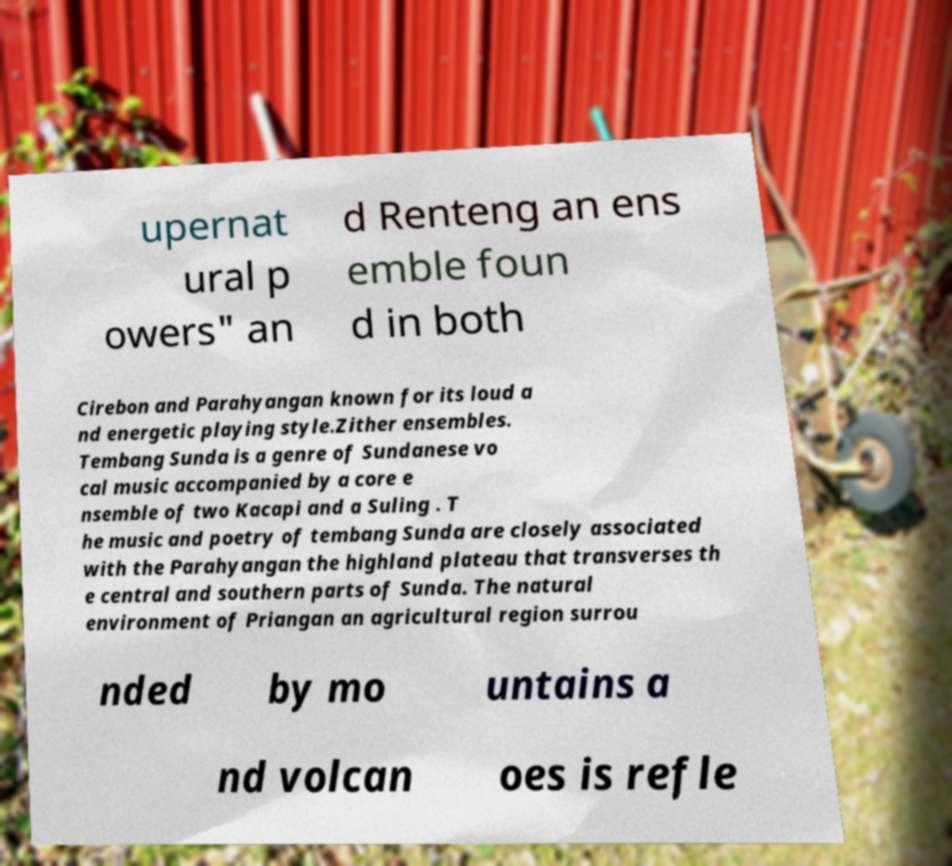I need the written content from this picture converted into text. Can you do that? upernat ural p owers" an d Renteng an ens emble foun d in both Cirebon and Parahyangan known for its loud a nd energetic playing style.Zither ensembles. Tembang Sunda is a genre of Sundanese vo cal music accompanied by a core e nsemble of two Kacapi and a Suling . T he music and poetry of tembang Sunda are closely associated with the Parahyangan the highland plateau that transverses th e central and southern parts of Sunda. The natural environment of Priangan an agricultural region surrou nded by mo untains a nd volcan oes is refle 